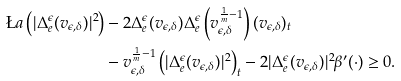<formula> <loc_0><loc_0><loc_500><loc_500>\L a \left ( | \Delta _ { e } ^ { \epsilon } ( v _ { \epsilon , \delta } ) | ^ { 2 } \right ) & - 2 \Delta _ { e } ^ { \epsilon } ( v _ { \epsilon , \delta } ) \Delta _ { e } ^ { \epsilon } \left ( v _ { \epsilon , \delta } ^ { \frac { 1 } { m } - 1 } \right ) ( v _ { \epsilon , \delta } ) _ { t } \\ & - v _ { \epsilon , \delta } ^ { \frac { 1 } { m } - 1 } \left ( | \Delta _ { e } ^ { \epsilon } ( v _ { \epsilon , \delta } ) | ^ { 2 } \right ) _ { t } - 2 | \Delta _ { e } ^ { \epsilon } ( v _ { \epsilon , \delta } ) | ^ { 2 } \beta ^ { \prime } ( \cdot ) \geq 0 .</formula> 